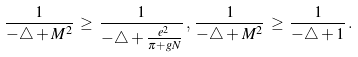<formula> <loc_0><loc_0><loc_500><loc_500>\frac { 1 } { - \triangle + M ^ { 2 } } \, \geq \, \frac { 1 } { - \triangle + \frac { e ^ { 2 } } { \pi + g N } } \, , \, \frac { 1 } { - \triangle + M ^ { 2 } } \, \geq \, \frac { 1 } { - \triangle + 1 } \, .</formula> 